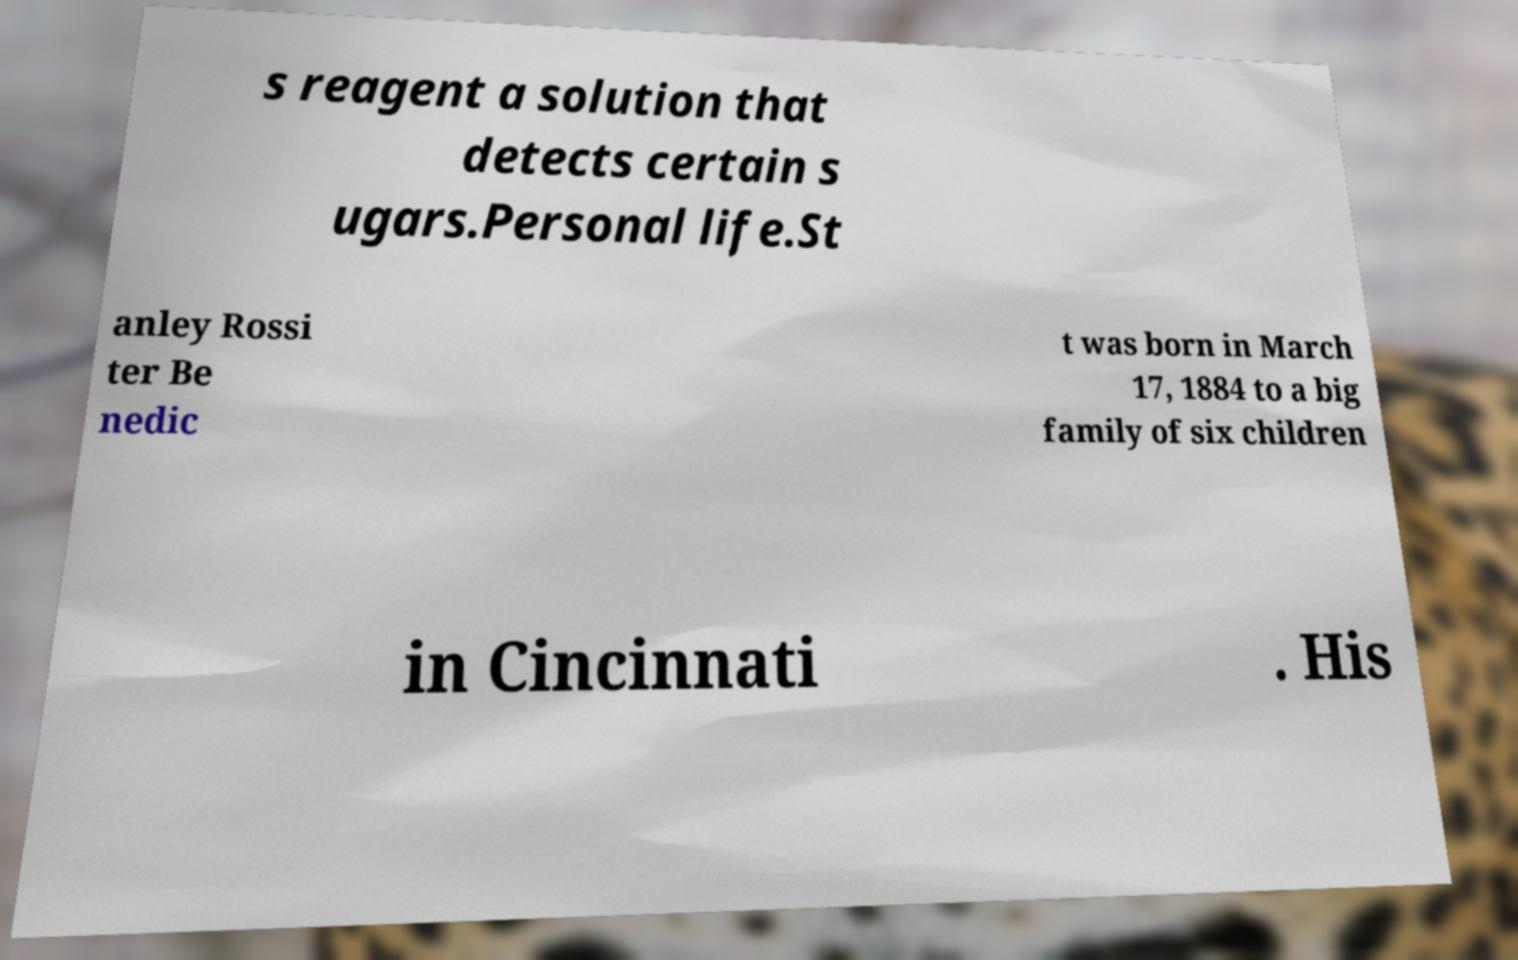Can you accurately transcribe the text from the provided image for me? s reagent a solution that detects certain s ugars.Personal life.St anley Rossi ter Be nedic t was born in March 17, 1884 to a big family of six children in Cincinnati . His 